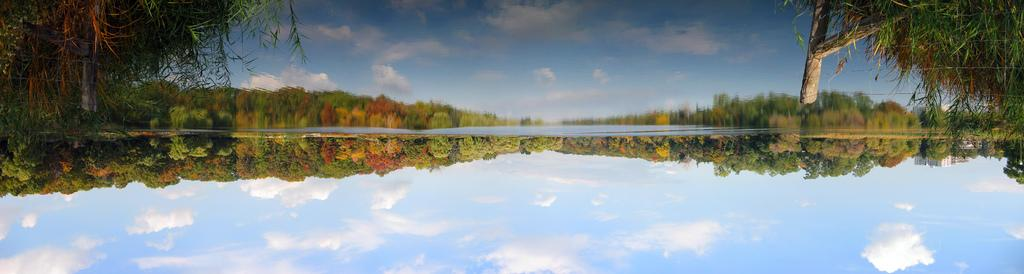What type of vegetation is present in the image? There is a group of trees in the image. What part of the natural environment is visible in the image? The sky is visible in the image. What is in the foreground of the image? There is water in the foreground of the image. What can be seen in the water in the image? The reflection of trees and the sky can be seen in the water. How many times does the expert sneeze in the image? There is no expert present in the image, and therefore no sneezing can be observed. Can you describe the steps taken by the trees in the image? Trees are stationary objects and do not take steps; they remain rooted in the ground. 